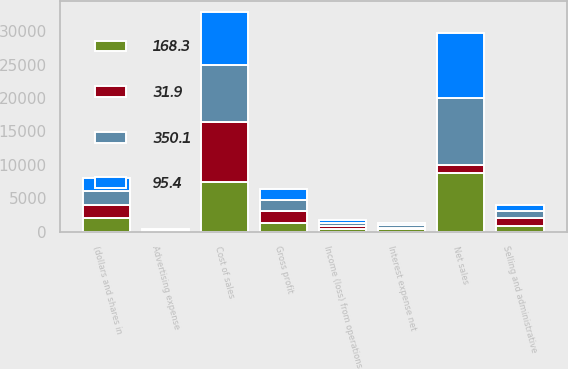<chart> <loc_0><loc_0><loc_500><loc_500><stacked_bar_chart><ecel><fcel>(dollars and shares in<fcel>Net sales<fcel>Cost of sales<fcel>Gross profit<fcel>Selling and administrative<fcel>Advertising expense<fcel>Income (loss) from operations<fcel>Interest expense net<nl><fcel>31.9<fcel>2013<fcel>1120.9<fcel>9008.3<fcel>1760.3<fcel>1120.9<fcel>130.8<fcel>508.6<fcel>250.1<nl><fcel>350.1<fcel>2012<fcel>10128.2<fcel>8458.6<fcel>1669.6<fcel>1029.5<fcel>129.5<fcel>510.6<fcel>307.4<nl><fcel>95.4<fcel>2011<fcel>9602.4<fcel>8018.9<fcel>1583.5<fcel>990.1<fcel>122.7<fcel>470.7<fcel>324.2<nl><fcel>168.3<fcel>2010<fcel>8801.2<fcel>7410.4<fcel>1390.8<fcel>932.1<fcel>106<fcel>352.7<fcel>391.9<nl></chart> 